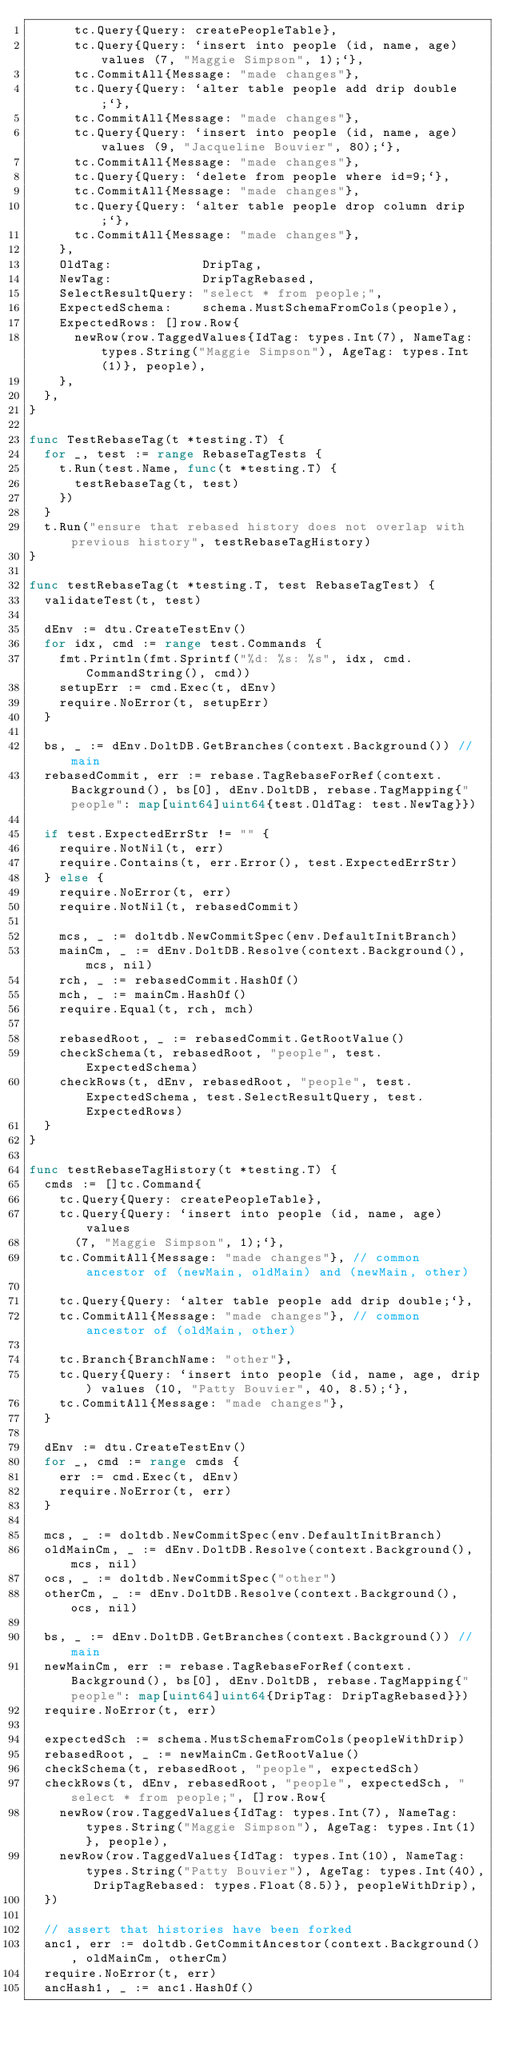Convert code to text. <code><loc_0><loc_0><loc_500><loc_500><_Go_>			tc.Query{Query: createPeopleTable},
			tc.Query{Query: `insert into people (id, name, age) values (7, "Maggie Simpson", 1);`},
			tc.CommitAll{Message: "made changes"},
			tc.Query{Query: `alter table people add drip double;`},
			tc.CommitAll{Message: "made changes"},
			tc.Query{Query: `insert into people (id, name, age) values (9, "Jacqueline Bouvier", 80);`},
			tc.CommitAll{Message: "made changes"},
			tc.Query{Query: `delete from people where id=9;`},
			tc.CommitAll{Message: "made changes"},
			tc.Query{Query: `alter table people drop column drip;`},
			tc.CommitAll{Message: "made changes"},
		},
		OldTag:            DripTag,
		NewTag:            DripTagRebased,
		SelectResultQuery: "select * from people;",
		ExpectedSchema:    schema.MustSchemaFromCols(people),
		ExpectedRows: []row.Row{
			newRow(row.TaggedValues{IdTag: types.Int(7), NameTag: types.String("Maggie Simpson"), AgeTag: types.Int(1)}, people),
		},
	},
}

func TestRebaseTag(t *testing.T) {
	for _, test := range RebaseTagTests {
		t.Run(test.Name, func(t *testing.T) {
			testRebaseTag(t, test)
		})
	}
	t.Run("ensure that rebased history does not overlap with previous history", testRebaseTagHistory)
}

func testRebaseTag(t *testing.T, test RebaseTagTest) {
	validateTest(t, test)

	dEnv := dtu.CreateTestEnv()
	for idx, cmd := range test.Commands {
		fmt.Println(fmt.Sprintf("%d: %s: %s", idx, cmd.CommandString(), cmd))
		setupErr := cmd.Exec(t, dEnv)
		require.NoError(t, setupErr)
	}

	bs, _ := dEnv.DoltDB.GetBranches(context.Background()) // main
	rebasedCommit, err := rebase.TagRebaseForRef(context.Background(), bs[0], dEnv.DoltDB, rebase.TagMapping{"people": map[uint64]uint64{test.OldTag: test.NewTag}})

	if test.ExpectedErrStr != "" {
		require.NotNil(t, err)
		require.Contains(t, err.Error(), test.ExpectedErrStr)
	} else {
		require.NoError(t, err)
		require.NotNil(t, rebasedCommit)

		mcs, _ := doltdb.NewCommitSpec(env.DefaultInitBranch)
		mainCm, _ := dEnv.DoltDB.Resolve(context.Background(), mcs, nil)
		rch, _ := rebasedCommit.HashOf()
		mch, _ := mainCm.HashOf()
		require.Equal(t, rch, mch)

		rebasedRoot, _ := rebasedCommit.GetRootValue()
		checkSchema(t, rebasedRoot, "people", test.ExpectedSchema)
		checkRows(t, dEnv, rebasedRoot, "people", test.ExpectedSchema, test.SelectResultQuery, test.ExpectedRows)
	}
}

func testRebaseTagHistory(t *testing.T) {
	cmds := []tc.Command{
		tc.Query{Query: createPeopleTable},
		tc.Query{Query: `insert into people (id, name, age) values 
			(7, "Maggie Simpson", 1);`},
		tc.CommitAll{Message: "made changes"}, // common ancestor of (newMain, oldMain) and (newMain, other)

		tc.Query{Query: `alter table people add drip double;`},
		tc.CommitAll{Message: "made changes"}, // common ancestor of (oldMain, other)

		tc.Branch{BranchName: "other"},
		tc.Query{Query: `insert into people (id, name, age, drip) values (10, "Patty Bouvier", 40, 8.5);`},
		tc.CommitAll{Message: "made changes"},
	}

	dEnv := dtu.CreateTestEnv()
	for _, cmd := range cmds {
		err := cmd.Exec(t, dEnv)
		require.NoError(t, err)
	}

	mcs, _ := doltdb.NewCommitSpec(env.DefaultInitBranch)
	oldMainCm, _ := dEnv.DoltDB.Resolve(context.Background(), mcs, nil)
	ocs, _ := doltdb.NewCommitSpec("other")
	otherCm, _ := dEnv.DoltDB.Resolve(context.Background(), ocs, nil)

	bs, _ := dEnv.DoltDB.GetBranches(context.Background()) // main
	newMainCm, err := rebase.TagRebaseForRef(context.Background(), bs[0], dEnv.DoltDB, rebase.TagMapping{"people": map[uint64]uint64{DripTag: DripTagRebased}})
	require.NoError(t, err)

	expectedSch := schema.MustSchemaFromCols(peopleWithDrip)
	rebasedRoot, _ := newMainCm.GetRootValue()
	checkSchema(t, rebasedRoot, "people", expectedSch)
	checkRows(t, dEnv, rebasedRoot, "people", expectedSch, "select * from people;", []row.Row{
		newRow(row.TaggedValues{IdTag: types.Int(7), NameTag: types.String("Maggie Simpson"), AgeTag: types.Int(1)}, people),
		newRow(row.TaggedValues{IdTag: types.Int(10), NameTag: types.String("Patty Bouvier"), AgeTag: types.Int(40), DripTagRebased: types.Float(8.5)}, peopleWithDrip),
	})

	// assert that histories have been forked
	anc1, err := doltdb.GetCommitAncestor(context.Background(), oldMainCm, otherCm)
	require.NoError(t, err)
	ancHash1, _ := anc1.HashOf()
</code> 